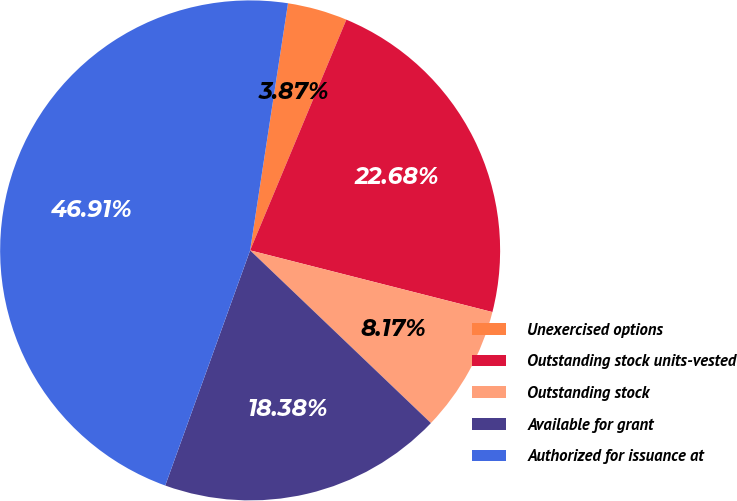Convert chart. <chart><loc_0><loc_0><loc_500><loc_500><pie_chart><fcel>Unexercised options<fcel>Outstanding stock units-vested<fcel>Outstanding stock<fcel>Available for grant<fcel>Authorized for issuance at<nl><fcel>3.87%<fcel>22.68%<fcel>8.17%<fcel>18.38%<fcel>46.91%<nl></chart> 